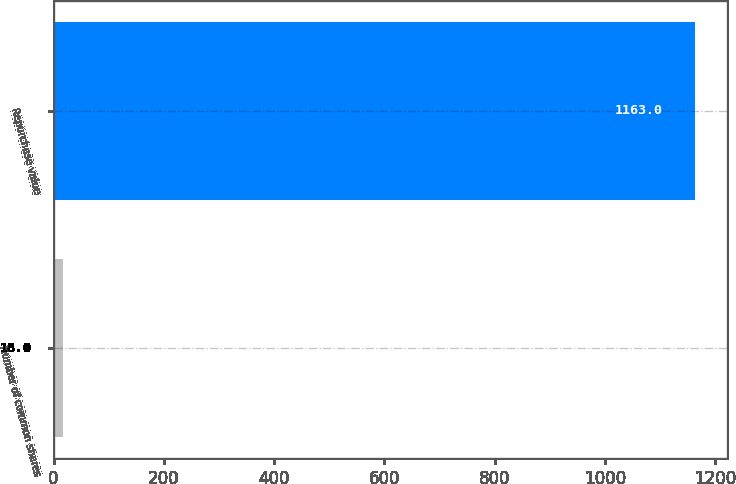Convert chart. <chart><loc_0><loc_0><loc_500><loc_500><bar_chart><fcel>Number of common shares<fcel>Repurchase value<nl><fcel>18<fcel>1163<nl></chart> 